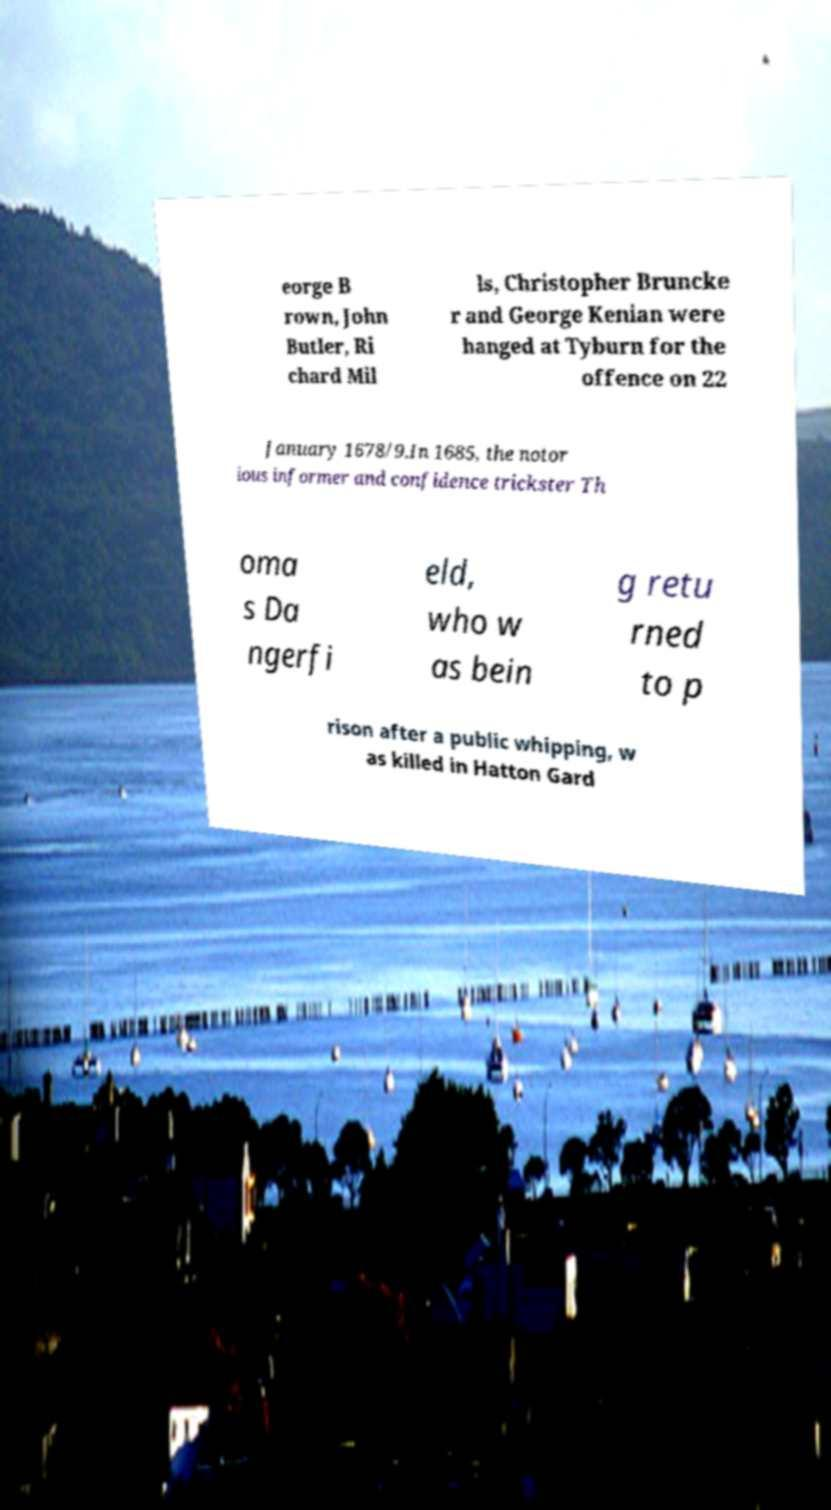Could you extract and type out the text from this image? eorge B rown, John Butler, Ri chard Mil ls, Christopher Bruncke r and George Kenian were hanged at Tyburn for the offence on 22 January 1678/9.In 1685, the notor ious informer and confidence trickster Th oma s Da ngerfi eld, who w as bein g retu rned to p rison after a public whipping, w as killed in Hatton Gard 